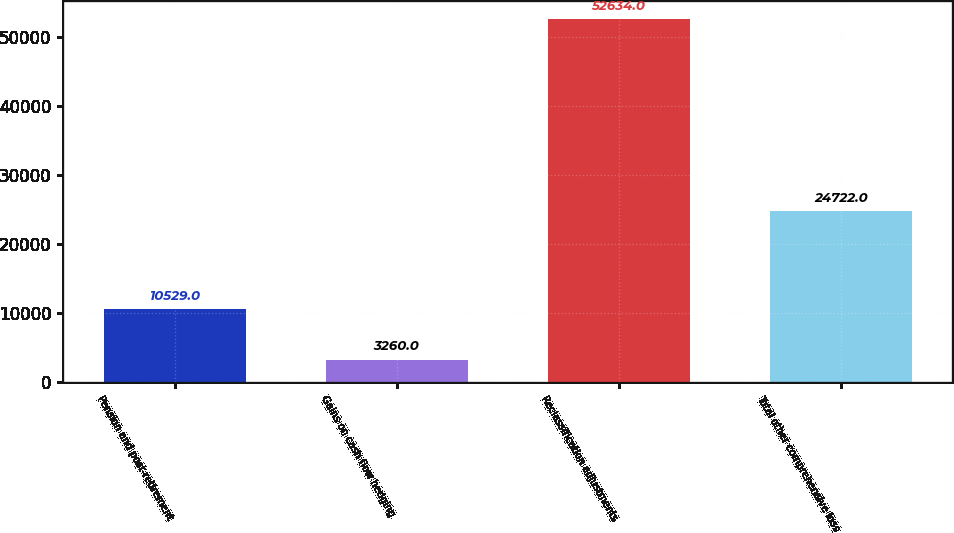Convert chart. <chart><loc_0><loc_0><loc_500><loc_500><bar_chart><fcel>Pension and post-retirement<fcel>Gains on cash flow hedging<fcel>Reclassification adjustments<fcel>Total other comprehensive loss<nl><fcel>10529<fcel>3260<fcel>52634<fcel>24722<nl></chart> 